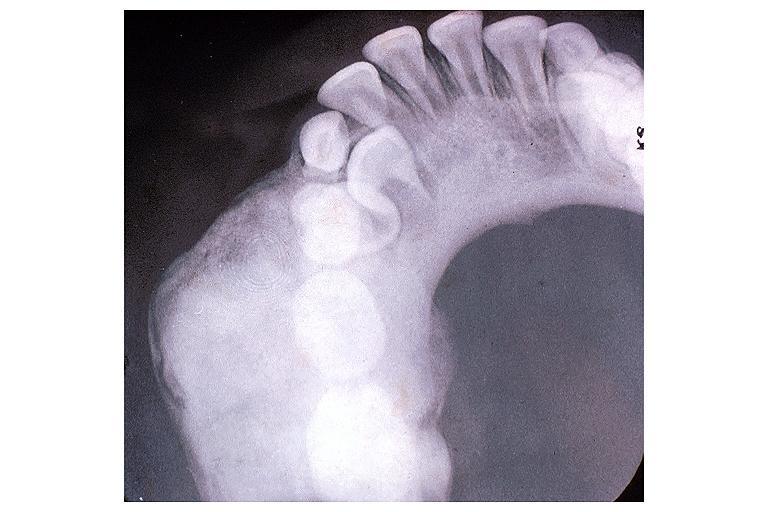does this image show osteoblastoma?
Answer the question using a single word or phrase. Yes 